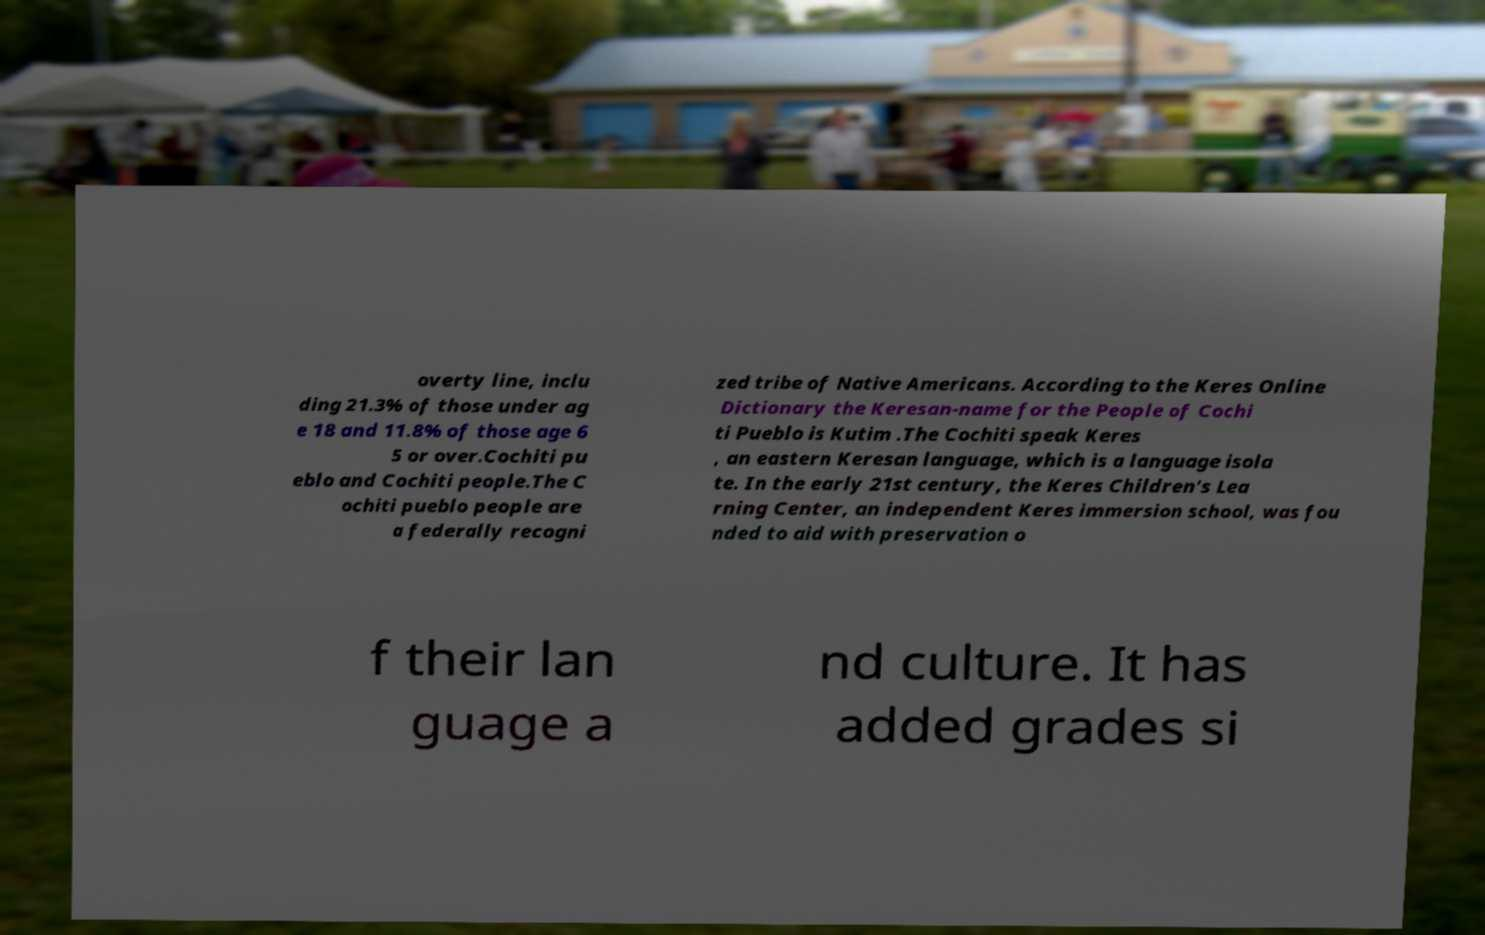Can you read and provide the text displayed in the image?This photo seems to have some interesting text. Can you extract and type it out for me? overty line, inclu ding 21.3% of those under ag e 18 and 11.8% of those age 6 5 or over.Cochiti pu eblo and Cochiti people.The C ochiti pueblo people are a federally recogni zed tribe of Native Americans. According to the Keres Online Dictionary the Keresan-name for the People of Cochi ti Pueblo is Kutim .The Cochiti speak Keres , an eastern Keresan language, which is a language isola te. In the early 21st century, the Keres Children's Lea rning Center, an independent Keres immersion school, was fou nded to aid with preservation o f their lan guage a nd culture. It has added grades si 